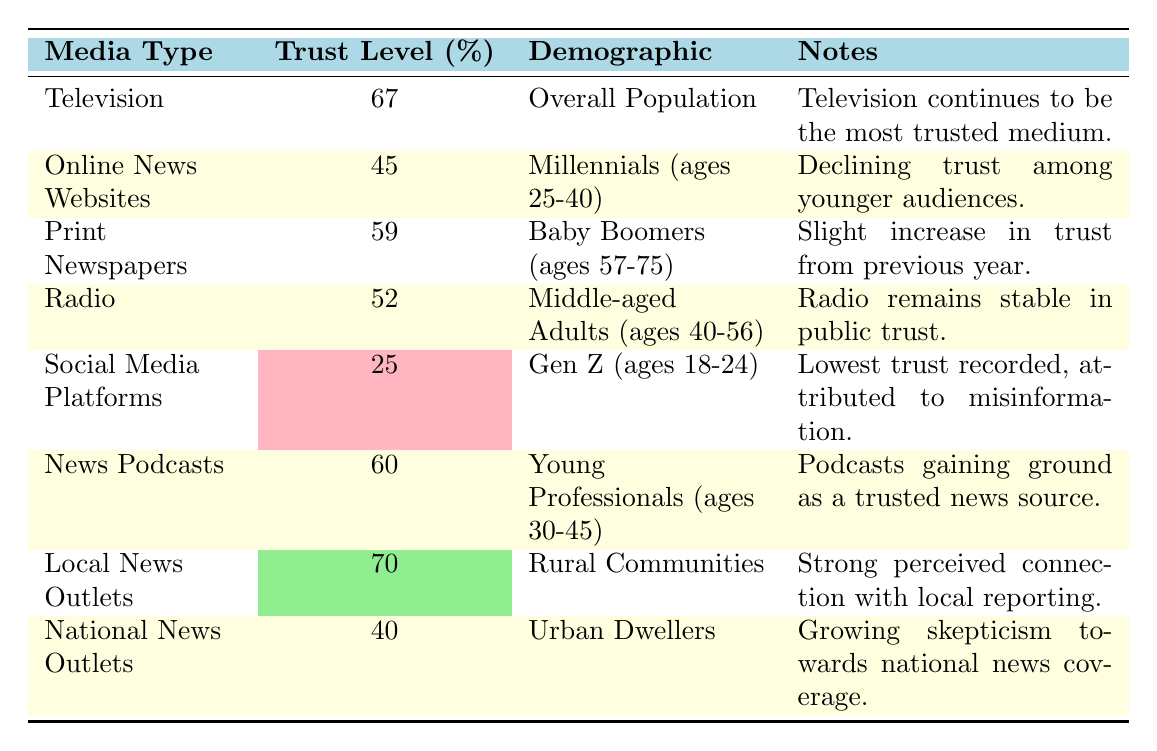What is the trust level for Television? The trust level for Television is explicitly stated in the table as 67%.
Answer: 67% Which demographic has the highest trust level in media? The demographic with the highest trust level is Rural Communities, as they trust Local News Outlets at 70%.
Answer: Rural Communities What is the trust level for Social Media Platforms? The table indicates that the trust level for Social Media Platforms is 25%.
Answer: 25% Is the trust level for National News Outlets above or below 50%? The trust level for National News Outlets is 40%, which is below 50%.
Answer: Below Which media type is trusted the least by Gen Z? The table shows that Social Media Platforms have the lowest trust level among Gen Z, at 25%.
Answer: Social Media Platforms What is the difference in trust level between Local News Outlets and Online News Websites? Local News Outlets have a trust level of 70%, while Online News Websites have a trust level of 45%. The difference is 70 - 45 = 25%.
Answer: 25% What media type shows a slight increase in trust among Baby Boomers? Print Newspapers show a slight increase in trust among Baby Boomers, as noted in the table.
Answer: Print Newspapers If you average the trust levels of Radio and News Podcasts, what do you get? The trust level for Radio is 52% and for News Podcasts is 60%. The average is (52 + 60) / 2 = 56%.
Answer: 56% Is there a general trend in trust among younger demographics according to the table? Yes, the data suggests a trend of declining trust among younger demographics, particularly evident in Online News Websites for Millennials and Social Media Platforms for Gen Z.
Answer: Yes Which demographic trusts Print Newspapers the most? Baby Boomers (ages 57-75) have the highest trust in Print Newspapers, with a level of 59%.
Answer: Baby Boomers 